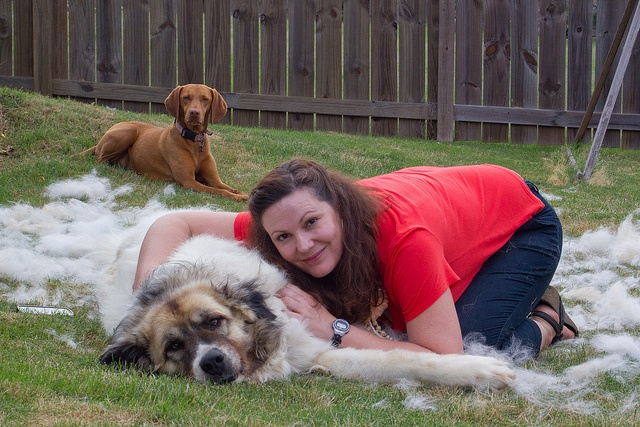Describe the objects in this image and their specific colors. I can see people in black, red, brown, and darkgray tones, dog in black, darkgray, lightgray, and gray tones, dog in black, maroon, brown, and gray tones, and clock in black, gray, and darkgray tones in this image. 